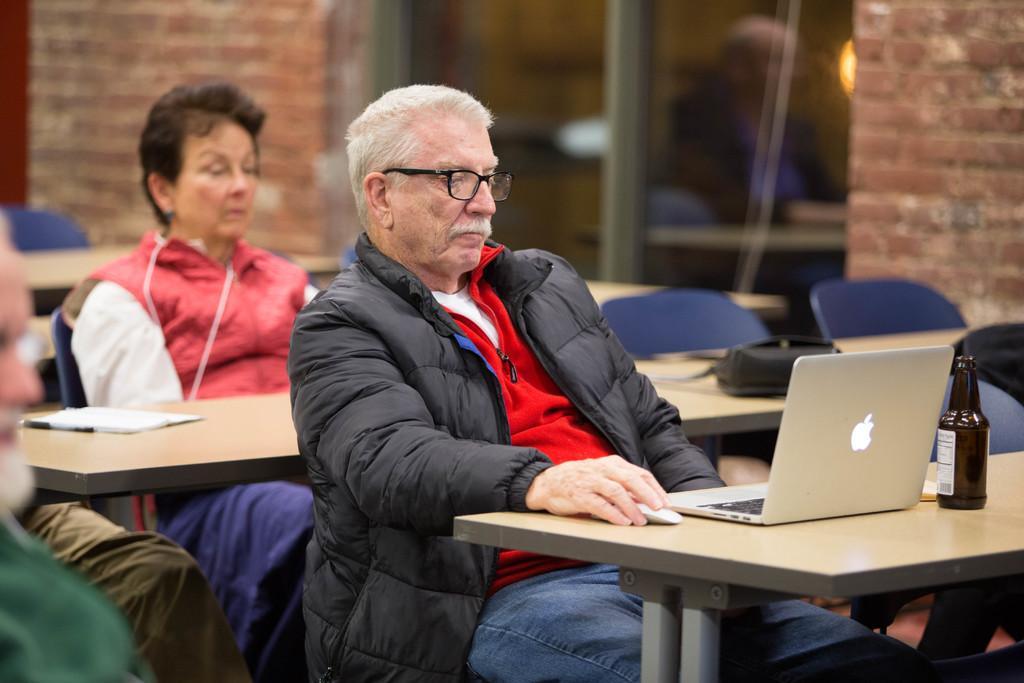How would you summarize this image in a sentence or two? In a picture we can see a man and a women are sitting on a chair. On the table there is a system and water bottle is placed. This man is wearing a spectacle and a black color jacket, the women is wearing a red color jacket. 